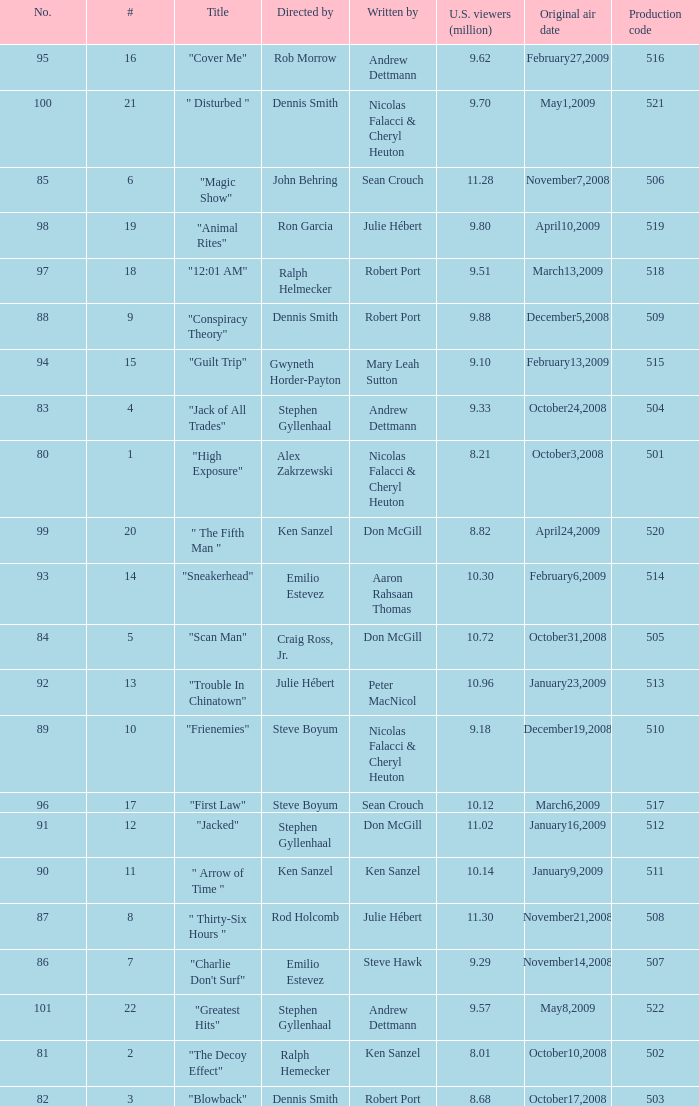What is the production code for the episode that had 9.18 million viewers (U.S.)? 510.0. 